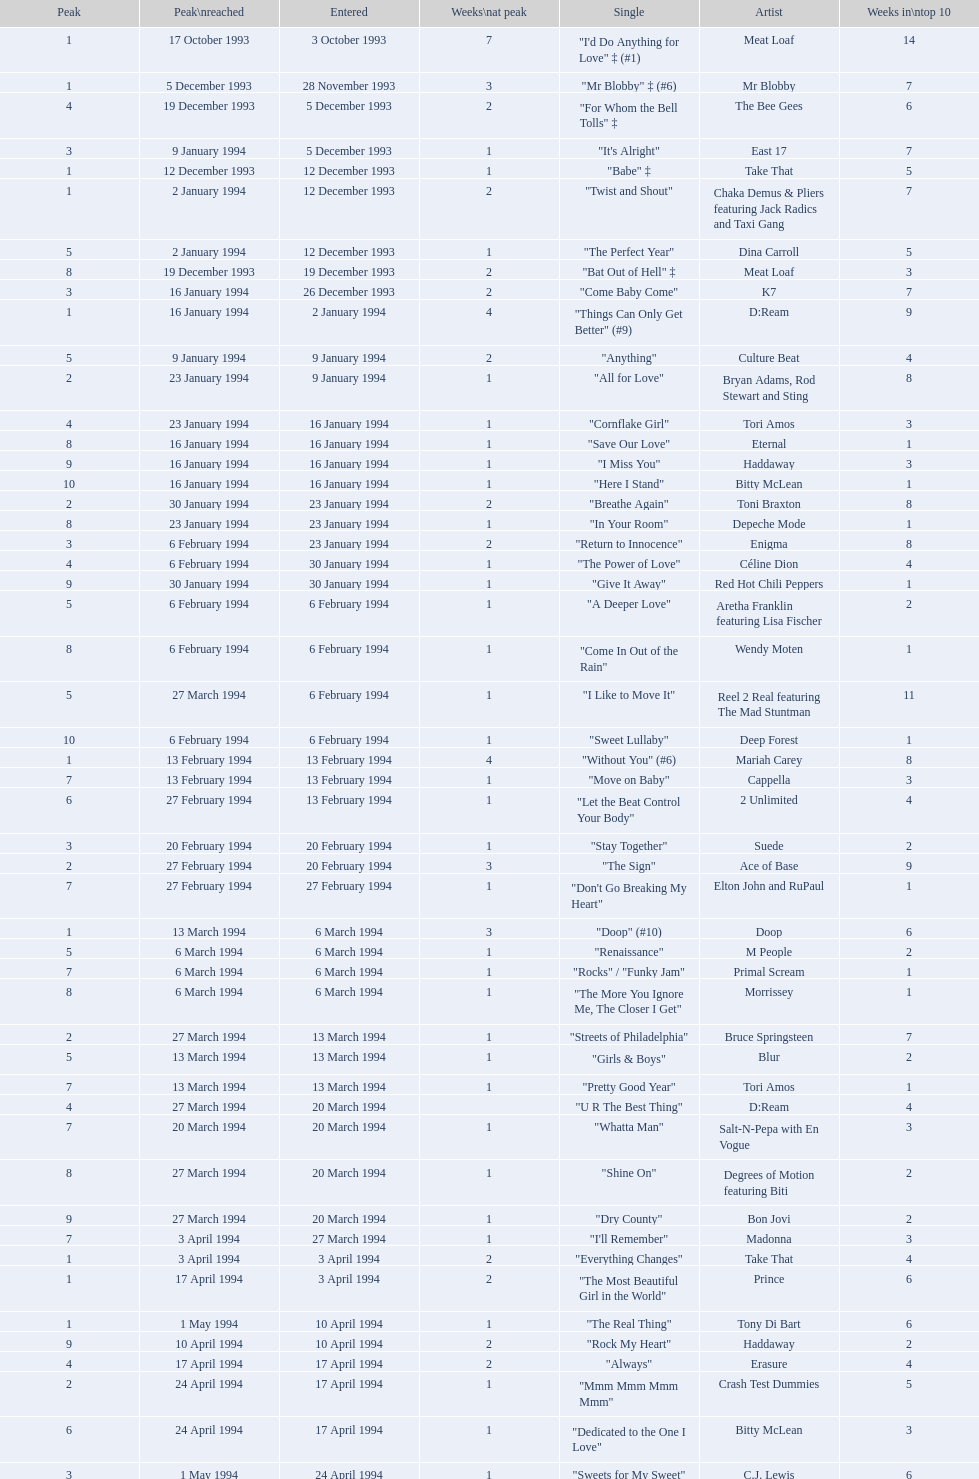Would you be able to parse every entry in this table? {'header': ['Peak', 'Peak\\nreached', 'Entered', 'Weeks\\nat peak', 'Single', 'Artist', 'Weeks in\\ntop 10'], 'rows': [['1', '17 October 1993', '3 October 1993', '7', '"I\'d Do Anything for Love" ‡ (#1)', 'Meat Loaf', '14'], ['1', '5 December 1993', '28 November 1993', '3', '"Mr Blobby" ‡ (#6)', 'Mr Blobby', '7'], ['4', '19 December 1993', '5 December 1993', '2', '"For Whom the Bell Tolls" ‡', 'The Bee Gees', '6'], ['3', '9 January 1994', '5 December 1993', '1', '"It\'s Alright"', 'East 17', '7'], ['1', '12 December 1993', '12 December 1993', '1', '"Babe" ‡', 'Take That', '5'], ['1', '2 January 1994', '12 December 1993', '2', '"Twist and Shout"', 'Chaka Demus & Pliers featuring Jack Radics and Taxi Gang', '7'], ['5', '2 January 1994', '12 December 1993', '1', '"The Perfect Year"', 'Dina Carroll', '5'], ['8', '19 December 1993', '19 December 1993', '2', '"Bat Out of Hell" ‡', 'Meat Loaf', '3'], ['3', '16 January 1994', '26 December 1993', '2', '"Come Baby Come"', 'K7', '7'], ['1', '16 January 1994', '2 January 1994', '4', '"Things Can Only Get Better" (#9)', 'D:Ream', '9'], ['5', '9 January 1994', '9 January 1994', '2', '"Anything"', 'Culture Beat', '4'], ['2', '23 January 1994', '9 January 1994', '1', '"All for Love"', 'Bryan Adams, Rod Stewart and Sting', '8'], ['4', '23 January 1994', '16 January 1994', '1', '"Cornflake Girl"', 'Tori Amos', '3'], ['8', '16 January 1994', '16 January 1994', '1', '"Save Our Love"', 'Eternal', '1'], ['9', '16 January 1994', '16 January 1994', '1', '"I Miss You"', 'Haddaway', '3'], ['10', '16 January 1994', '16 January 1994', '1', '"Here I Stand"', 'Bitty McLean', '1'], ['2', '30 January 1994', '23 January 1994', '2', '"Breathe Again"', 'Toni Braxton', '8'], ['8', '23 January 1994', '23 January 1994', '1', '"In Your Room"', 'Depeche Mode', '1'], ['3', '6 February 1994', '23 January 1994', '2', '"Return to Innocence"', 'Enigma', '8'], ['4', '6 February 1994', '30 January 1994', '1', '"The Power of Love"', 'Céline Dion', '4'], ['9', '30 January 1994', '30 January 1994', '1', '"Give It Away"', 'Red Hot Chili Peppers', '1'], ['5', '6 February 1994', '6 February 1994', '1', '"A Deeper Love"', 'Aretha Franklin featuring Lisa Fischer', '2'], ['8', '6 February 1994', '6 February 1994', '1', '"Come In Out of the Rain"', 'Wendy Moten', '1'], ['5', '27 March 1994', '6 February 1994', '1', '"I Like to Move It"', 'Reel 2 Real featuring The Mad Stuntman', '11'], ['10', '6 February 1994', '6 February 1994', '1', '"Sweet Lullaby"', 'Deep Forest', '1'], ['1', '13 February 1994', '13 February 1994', '4', '"Without You" (#6)', 'Mariah Carey', '8'], ['7', '13 February 1994', '13 February 1994', '1', '"Move on Baby"', 'Cappella', '3'], ['6', '27 February 1994', '13 February 1994', '1', '"Let the Beat Control Your Body"', '2 Unlimited', '4'], ['3', '20 February 1994', '20 February 1994', '1', '"Stay Together"', 'Suede', '2'], ['2', '27 February 1994', '20 February 1994', '3', '"The Sign"', 'Ace of Base', '9'], ['7', '27 February 1994', '27 February 1994', '1', '"Don\'t Go Breaking My Heart"', 'Elton John and RuPaul', '1'], ['1', '13 March 1994', '6 March 1994', '3', '"Doop" (#10)', 'Doop', '6'], ['5', '6 March 1994', '6 March 1994', '1', '"Renaissance"', 'M People', '2'], ['7', '6 March 1994', '6 March 1994', '1', '"Rocks" / "Funky Jam"', 'Primal Scream', '1'], ['8', '6 March 1994', '6 March 1994', '1', '"The More You Ignore Me, The Closer I Get"', 'Morrissey', '1'], ['2', '27 March 1994', '13 March 1994', '1', '"Streets of Philadelphia"', 'Bruce Springsteen', '7'], ['5', '13 March 1994', '13 March 1994', '1', '"Girls & Boys"', 'Blur', '2'], ['7', '13 March 1994', '13 March 1994', '1', '"Pretty Good Year"', 'Tori Amos', '1'], ['4', '27 March 1994', '20 March 1994', '', '"U R The Best Thing"', 'D:Ream', '4'], ['7', '20 March 1994', '20 March 1994', '1', '"Whatta Man"', 'Salt-N-Pepa with En Vogue', '3'], ['8', '27 March 1994', '20 March 1994', '1', '"Shine On"', 'Degrees of Motion featuring Biti', '2'], ['9', '27 March 1994', '20 March 1994', '1', '"Dry County"', 'Bon Jovi', '2'], ['7', '3 April 1994', '27 March 1994', '1', '"I\'ll Remember"', 'Madonna', '3'], ['1', '3 April 1994', '3 April 1994', '2', '"Everything Changes"', 'Take That', '4'], ['1', '17 April 1994', '3 April 1994', '2', '"The Most Beautiful Girl in the World"', 'Prince', '6'], ['1', '1 May 1994', '10 April 1994', '1', '"The Real Thing"', 'Tony Di Bart', '6'], ['9', '10 April 1994', '10 April 1994', '2', '"Rock My Heart"', 'Haddaway', '2'], ['4', '17 April 1994', '17 April 1994', '2', '"Always"', 'Erasure', '4'], ['2', '24 April 1994', '17 April 1994', '1', '"Mmm Mmm Mmm Mmm"', 'Crash Test Dummies', '5'], ['6', '24 April 1994', '17 April 1994', '1', '"Dedicated to the One I Love"', 'Bitty McLean', '3'], ['3', '1 May 1994', '24 April 1994', '1', '"Sweets for My Sweet"', 'C.J. Lewis', '6'], ['10', '24 April 1994', '24 April 1994', '1', '"I\'ll Stand by You"', 'The Pretenders', '1'], ['1', '8 May 1994', '1 May 1994', '1', '"Inside"', 'Stiltskin', '6'], ['7', '1 May 1994', '1 May 1994', '1', '"Light My Fire"', 'Clubhouse featuring Carl', '2'], ['1', '15 May 1994', '1 May 1994', '2', '"Come on You Reds"', 'Manchester United Football Squad featuring Status Quo', '7'], ['3', '15 May 1994', '8 May 1994', '2', '"Around the World"', 'East 17', '5'], ['8', '15 May 1994', '8 May 1994', '1', '"Just a Step from Heaven"', 'Eternal', '3'], ['1', '29 May 1994', '15 May 1994', '15', '"Love Is All Around" (#1)', 'Wet Wet Wet', '20'], ['6', '22 May 1994', '15 May 1994', '1', '"The Real Thing"', '2 Unlimited', '3'], ['8', '22 May 1994', '15 May 1994', '1', '"More to This World"', 'Bad Boys Inc', '2'], ['4', '29 May 1994', '22 May 1994', '2', '"Get-A-Way"', 'Maxx', '5'], ['4', '12 June 1994', '22 May 1994', '1', '"No Good (Start the Dance)"', 'The Prodigy', '6'], ['2', '5 June 1994', '29 May 1994', '3', '"Baby, I Love Your Way"', 'Big Mountain', '7'], ['9', '29 May 1994', '29 May 1994', '1', '"Carry Me Home"', 'Gloworm', '1'], ['6', '12 June 1994', '5 June 1994', '1', '"Absolutely Fabulous"', 'Absolutely Fabulous', '3'], ['3', '12 June 1994', '5 June 1994', '2', '"You Don\'t Love Me (No, No, No)"', 'Dawn Penn', '5'], ['10', '5 June 1994', '5 June 1994', '1', '"Since I Don\'t Have You"', 'Guns N Roses', '1'], ['5', '19 June 1994', '12 June 1994', '1', '"Don\'t Turn Around"', 'Ace of Base', '3'], ['3', '26 June 1994', '12 June 1994', '1', '"Swamp Thing"', 'The Grid', '8'], ['8', '19 June 1994', '12 June 1994', '1', '"Anytime You Need a Friend"', 'Mariah Carey', '2'], ['2', '26 June 1994', '19 June 1994', '7', '"I Swear" (#5)', 'All-4-One', '12'], ['7', '26 June 1994', '26 June 1994', '2', '"Go On Move"', 'Reel 2 Real featuring The Mad Stuntman', '2'], ['5', '17 July 1994', '26 June 1994', '1', '"Shine"', 'Aswad', '6'], ['10', '26 June 1994', '26 June 1994', '1', '"U & Me"', 'Cappella', '1'], ['3', '3 July 1994', '3 July 1994', '2', '"Love Ain\'t Here Anymore"', 'Take That', '3'], ['3', '17 July 1994', '3 July 1994', '3', '"(Meet) The Flintstones"', 'The B.C. 52s', '7'], ['8', '3 July 1994', '3 July 1994', '1', '"Word Up!"', 'GUN', '2'], ['7', '10 July 1994', '10 July 1994', '1', '"Everybody Gonfi-Gon"', '2 Cowboys', '2'], ['2', '14 August 1994', '10 July 1994', '2', '"Crazy for You" (#8)', 'Let Loose', '9'], ['5', '24 July 1994', '17 July 1994', '1', '"Regulate"', 'Warren G and Nate Dogg', '8'], ['10', '17 July 1994', '17 July 1994', '2', '"Everything is Alright (Uptight)"', 'C.J. Lewis', '2'], ['6', '24 July 1994', '24 July 1994', '1', '"Run to the Sun"', 'Erasure', '1'], ['4', '7 August 1994', '24 July 1994', '2', '"Searching"', 'China Black', '7'], ['1', '31 March 2013', '31 July 1994', '1', '"Let\'s Get Ready to Rhumble"', 'PJ & Duncan', '4'], ['8', '7 August 1994', '31 July 1994', '1', '"No More (I Can\'t Stand It)"', 'Maxx', '2'], ['2', '28 August 1994', '7 August 1994', '1', '"Compliments on Your Kiss"', 'Red Dragon with Brian and Tony Gold', '6'], ['6', '14 August 1994', '7 August 1994', '1', '"What\'s Up?"', 'DJ Miko', '4'], ['3', '4 September 1994', '14 August 1994', '1', '"7 Seconds"', "Youssou N'Dour featuring Neneh Cherry", '6'], ['10', '14 August 1994', '14 August 1994', '2', '"Live Forever"', 'Oasis', '2'], ['9', '21 August 1994', '21 August 1994', '1', '"Eighteen Strings"', 'Tinman', '1'], ['5', '4 September 1994', '28 August 1994', '1', '"I\'ll Make Love to You"', 'Boyz II Men', '5'], ['10', '28 August 1994', '28 August 1994', '1', '"Parklife"', 'Blur', '1'], ['2', '4 September 1994', '4 September 1994', '1', '"Confide in Me"', 'Kylie Minogue', '3'], ['2', '18 September 1994', '4 September 1994', '2', '"The Rhythm of the Night"', 'Corona', '6'], ['1', '11 September 1994', '11 September 1994', '4', '"Saturday Night" (#2)', 'Whigfield', '10'], ['3', '11 September 1994', '11 September 1994', '2', '"Endless Love"', 'Luther Vandross and Mariah Carey', '4'], ['9', '11 September 1994', '11 September 1994', '1', '"What\'s the Frequency, Kenneth"', 'R.E.M.', '2'], ['8', '18 September 1994', '11 September 1994', '1', '"Incredible"', 'M-Beat featuring General Levy', '3'], ['2', '2 October 1994', '18 September 1994', '3', '"Always" (#7)', 'Bon Jovi', '11'], ['4', '2 October 1994', '25 September 1994', '1', '"Hey Now (Girls Just Want to Have Fun)"', 'Cyndi Lauper', '6'], ['6', '25 September 1994', '25 September 1994', '1', '"Stay (I Missed You)"', 'Lisa Loeb and Nine Stories', '6'], ['7', '25 September 1994', '25 September 1994', '2', '"Steam"', 'East 17', '3'], ['5', '2 October 1994', '2 October 1994', '1', '"Secret"', 'Madonna', '2'], ['1', '23 October 1994', '2 October 1994', '4', '"Baby Come Back" (#4)', 'Pato Banton featuring Ali and Robin Campbell', '10'], ['4', '30 October 1994', '2 October 1994', '1', '"Sweetness"', 'Michelle Gayle', '6'], ['1', '9 October 1994', '9 October 1994', '2', '"Sure"', 'Take That', '3'], ['7', '16 October 1994', '16 October 1994', '1', '"Cigarettes & Alcohol"', 'Oasis', '1'], ['6', '30 October 1994', '16 October 1994', '1', '"Welcome to Tomorrow (Are You Ready?)"', 'Snap! featuring Summer', '4'], ['3', '6 November 1994', '16 October 1994', '1', '"She\'s Got That Vibe"', 'R. Kelly', '5'], ['9', '23 October 1994', '23 October 1994', '1', '"When We Dance"', 'Sting', '1'], ['4', '6 November 1994', '30 October 1994', '1', '"Oh Baby I..."', 'Eternal', '4'], ['9', '30 October 1994', '30 October 1994', '1', '"Some Girls"', 'Ultimate Kaos', '2'], ['2', '13 November 1994', '6 November 1994', '1', '"Another Night"', 'MC Sar and Real McCoy', '5'], ['4', '20 November 1994', '6 November 1994', '1', '"All I Wanna Do"', 'Sheryl Crow', '4'], ['1', '20 November 1994', '13 November 1994', '2', '"Let Me Be Your Fantasy"', 'Baby D', '5'], ['6', '20 November 1994', '13 November 1994', '1', '"Sight for Sore Eyes"', 'M People', '3'], ['9', '13 November 1994', '13 November 1994', '1', '"True Faith \'94"', 'New Order', '1'], ['3', '27 November 1994', '20 November 1994', '1', '"We Have All the Time in the World"', 'Louis Armstrong', '6'], ['4', '4 December 1994', '20 November 1994', '1', '"Crocodile Shoes"', 'Jimmy Nail', '7'], ['10', '20 November 1994', '20 November 1994', '1', '"Spin the Black Circle"', 'Pearl Jam', '1'], ['2', '27 November 1994', '27 November 1994', '1', '"Love Spreads"', 'The Stone Roses', '2'], ['1', '4 December 1994', '27 November 1994', '5', '"Stay Another Day" (#3)', 'East 17', '8'], ['2', '11 December 1994', '4 December 1994', '3', '"All I Want for Christmas Is You"', 'Mariah Carey', '5'], ['3', '11 December', '11 December 1994', '1', '"Power Rangers: The Official Single"', 'The Mighty RAW', '3'], ['1', '29 January 1995', '4 December 1994', '7', '"Think Twice" ♦', 'Celine Dion', '17'], ['2', '1 January 1995', '4 December 1994', '1', '"Love Me for a Reason" ♦', 'Boyzone', '8'], ['7', '11 December 1994', '11 December 1994', '1', '"Please Come Home for Christmas"', 'Bon Jovi', '2'], ['7', '1 January 1995', '11 December 1994', '1', '"Another Day" ♦', 'Whigfield', '2'], ['1', '8 January 1995', '18 December 1994', '3', '"Cotton Eye Joe" ♦', 'Rednex', '10'], ['5', '1 January 1995', '18 December 1994', '1', '"Them Girls, Them Girls" ♦', 'Zig and Zag', '4'], ['3', '25 December 1994', '25 December 1994', '1', '"Whatever"', 'Oasis', '4']]} This song released by celine dion spent 17 weeks on the uk singles chart in 1994, which one was it? "Think Twice". 